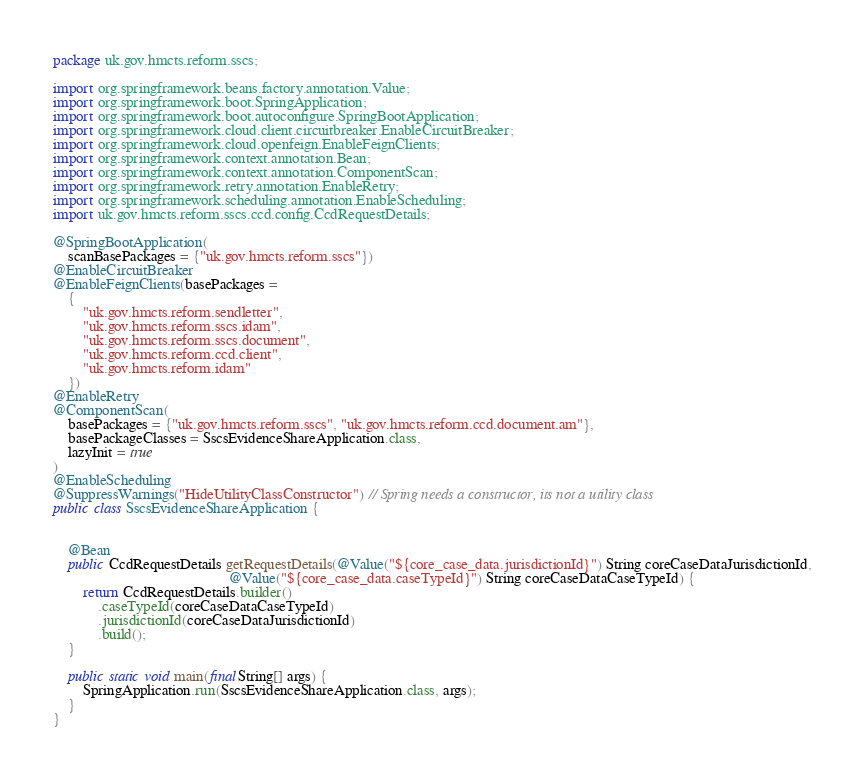Convert code to text. <code><loc_0><loc_0><loc_500><loc_500><_Java_>package uk.gov.hmcts.reform.sscs;

import org.springframework.beans.factory.annotation.Value;
import org.springframework.boot.SpringApplication;
import org.springframework.boot.autoconfigure.SpringBootApplication;
import org.springframework.cloud.client.circuitbreaker.EnableCircuitBreaker;
import org.springframework.cloud.openfeign.EnableFeignClients;
import org.springframework.context.annotation.Bean;
import org.springframework.context.annotation.ComponentScan;
import org.springframework.retry.annotation.EnableRetry;
import org.springframework.scheduling.annotation.EnableScheduling;
import uk.gov.hmcts.reform.sscs.ccd.config.CcdRequestDetails;

@SpringBootApplication(
    scanBasePackages = {"uk.gov.hmcts.reform.sscs"})
@EnableCircuitBreaker
@EnableFeignClients(basePackages =
    {
        "uk.gov.hmcts.reform.sendletter",
        "uk.gov.hmcts.reform.sscs.idam",
        "uk.gov.hmcts.reform.sscs.document",
        "uk.gov.hmcts.reform.ccd.client",
        "uk.gov.hmcts.reform.idam"
    })
@EnableRetry
@ComponentScan(
    basePackages = {"uk.gov.hmcts.reform.sscs", "uk.gov.hmcts.reform.ccd.document.am"},
    basePackageClasses = SscsEvidenceShareApplication.class,
    lazyInit = true
)
@EnableScheduling
@SuppressWarnings("HideUtilityClassConstructor") // Spring needs a constructor, its not a utility class
public class SscsEvidenceShareApplication {


    @Bean
    public CcdRequestDetails getRequestDetails(@Value("${core_case_data.jurisdictionId}") String coreCaseDataJurisdictionId,
                                               @Value("${core_case_data.caseTypeId}") String coreCaseDataCaseTypeId) {
        return CcdRequestDetails.builder()
            .caseTypeId(coreCaseDataCaseTypeId)
            .jurisdictionId(coreCaseDataJurisdictionId)
            .build();
    }

    public static void main(final String[] args) {
        SpringApplication.run(SscsEvidenceShareApplication.class, args);
    }
}
</code> 